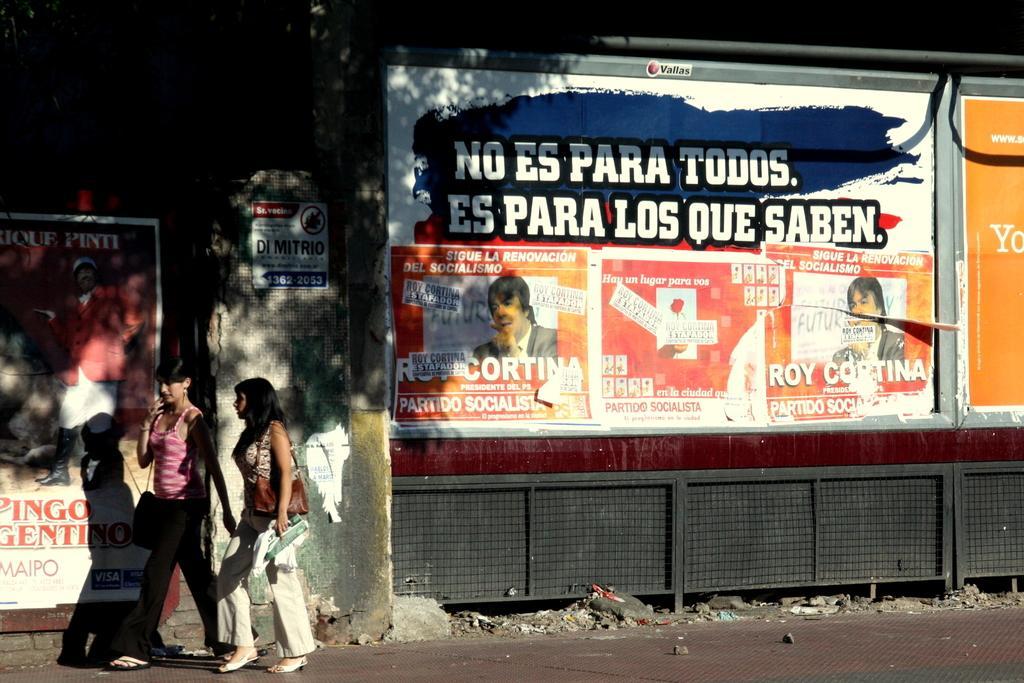Could you give a brief overview of what you see in this image? On the left side of the image we can see two ladies are walking and carrying bag. In the background of the image we can see wall, poster, board, rod, fencing. At the bottom of the image we can see some stones, road. 